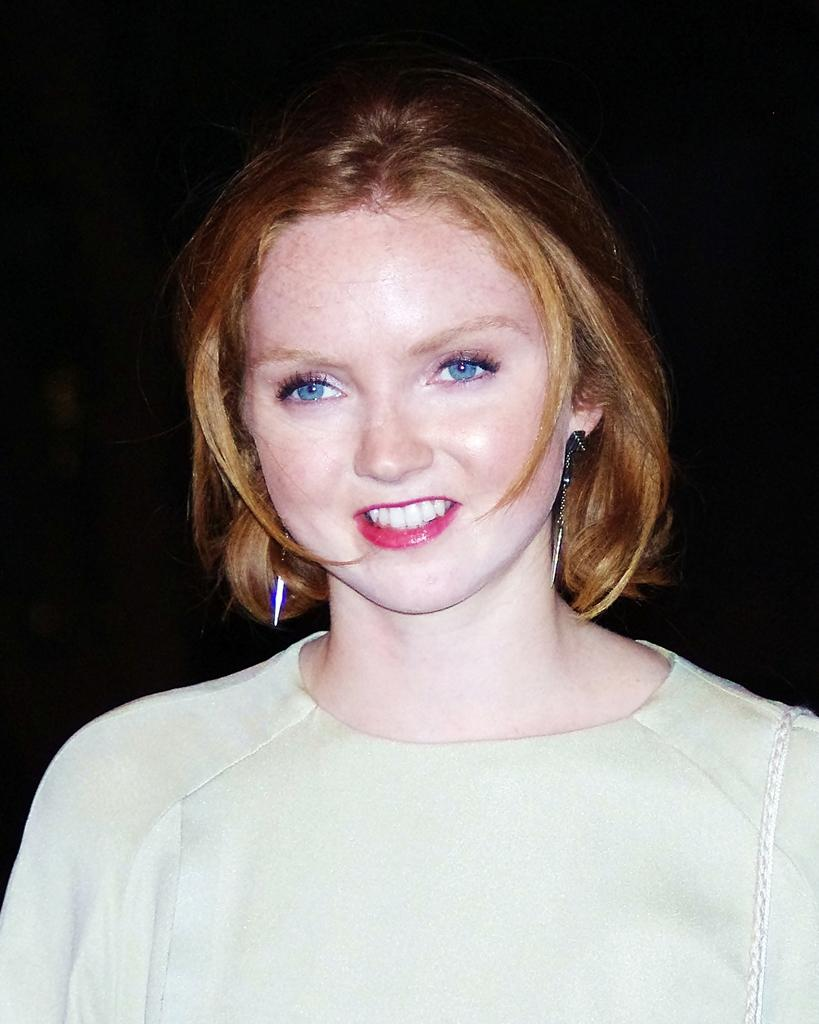Who is the main subject in the image? There is a girl in the image. What can be observed about the girl's eye color? The girl's eye is blue. What is the girl wearing in the image? The girl is wearing a white dress. What type of cobweb can be seen in the girl's hair in the image? There is no cobweb present in the girl's hair in the image. What type of oatmeal is the girl eating in the image? There is no oatmeal present in the image; the girl is not eating anything. 